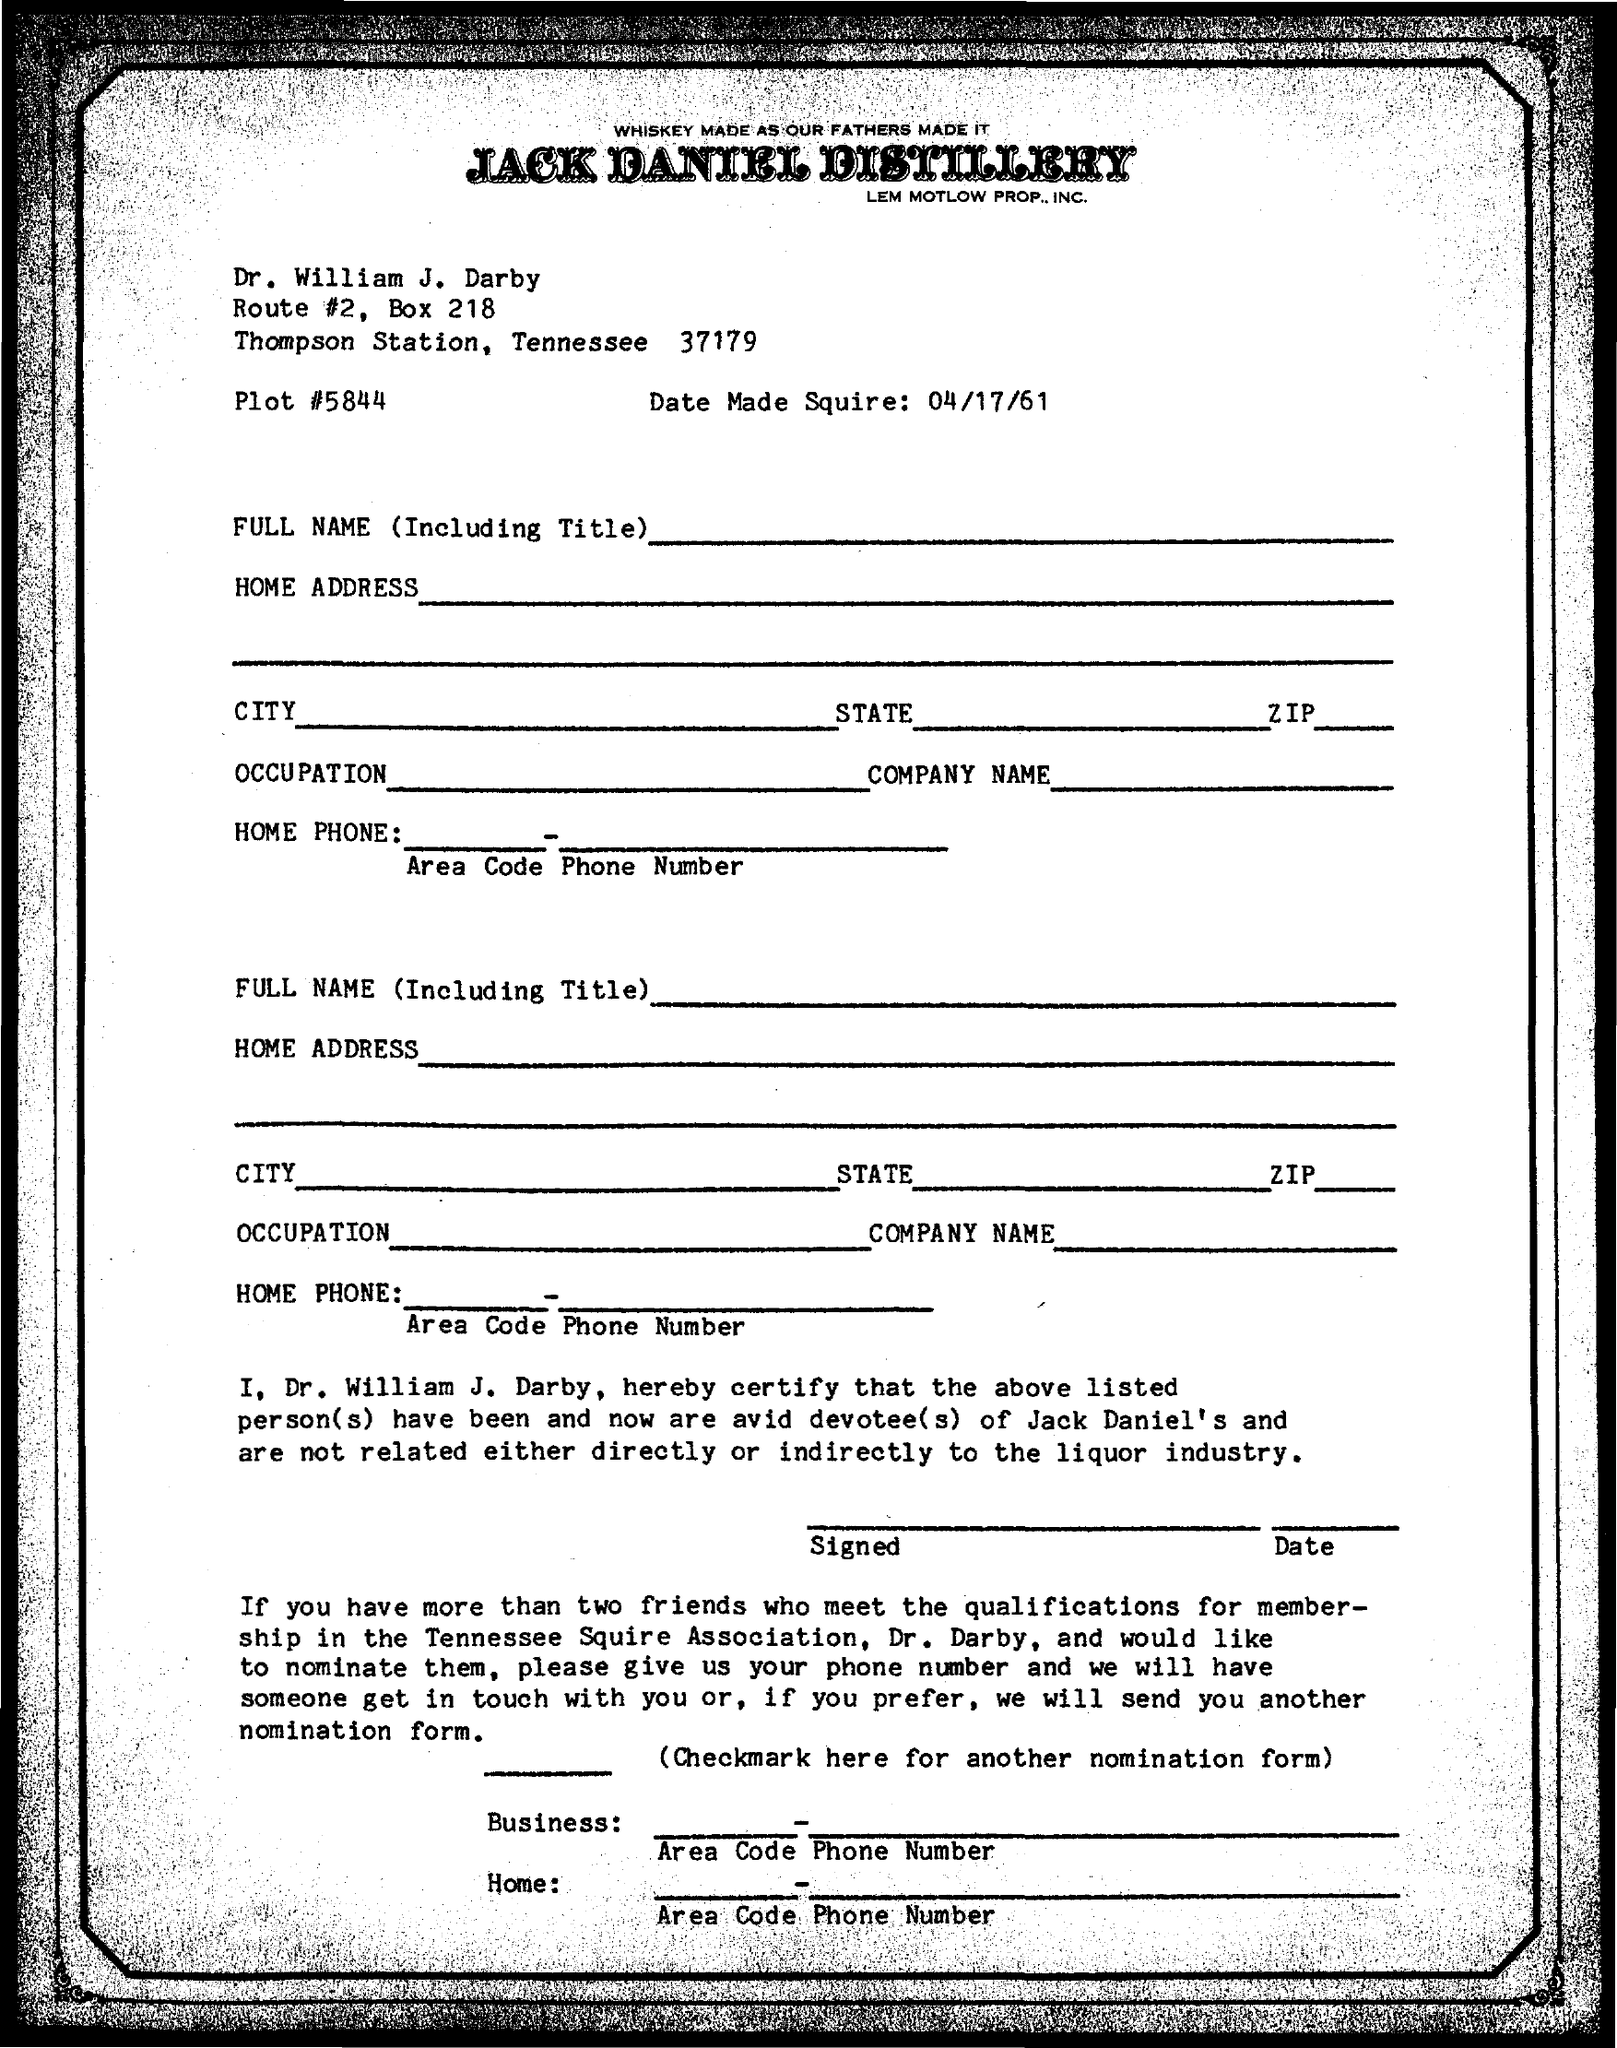List a handful of essential elements in this visual. The date is April 17th, 1961. The note pad is from the Jack Daniel Distillery. The letter is addressed to Dr. William J. Darby. 